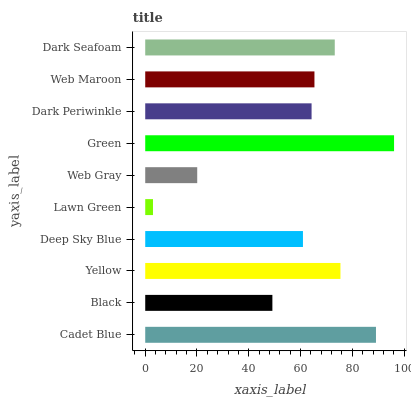Is Lawn Green the minimum?
Answer yes or no. Yes. Is Green the maximum?
Answer yes or no. Yes. Is Black the minimum?
Answer yes or no. No. Is Black the maximum?
Answer yes or no. No. Is Cadet Blue greater than Black?
Answer yes or no. Yes. Is Black less than Cadet Blue?
Answer yes or no. Yes. Is Black greater than Cadet Blue?
Answer yes or no. No. Is Cadet Blue less than Black?
Answer yes or no. No. Is Web Maroon the high median?
Answer yes or no. Yes. Is Dark Periwinkle the low median?
Answer yes or no. Yes. Is Cadet Blue the high median?
Answer yes or no. No. Is Web Gray the low median?
Answer yes or no. No. 